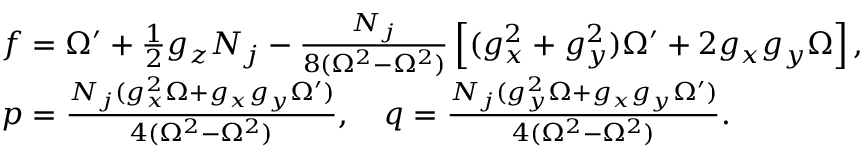<formula> <loc_0><loc_0><loc_500><loc_500>\begin{array} { r l } & { f = \Omega ^ { \prime } + \frac { 1 } { 2 } g _ { z } N _ { j } - \frac { N _ { j } } { 8 ( \Omega ^ { 2 } - \Omega ^ { 2 } ) } \left [ ( g _ { x } ^ { 2 } + g _ { y } ^ { 2 } ) \Omega ^ { \prime } + 2 g _ { x } g _ { y } \Omega \right ] , } \\ & { p = \frac { N _ { j } ( g _ { x } ^ { 2 } \Omega + g _ { x } g _ { y } \Omega ^ { \prime } ) } { 4 ( \Omega ^ { 2 } - \Omega ^ { 2 } ) } , \quad q = \frac { N _ { j } ( g _ { y } ^ { 2 } \Omega + g _ { x } g _ { y } \Omega ^ { \prime } ) } { 4 ( \Omega ^ { 2 } - \Omega ^ { 2 } ) } . } \end{array}</formula> 